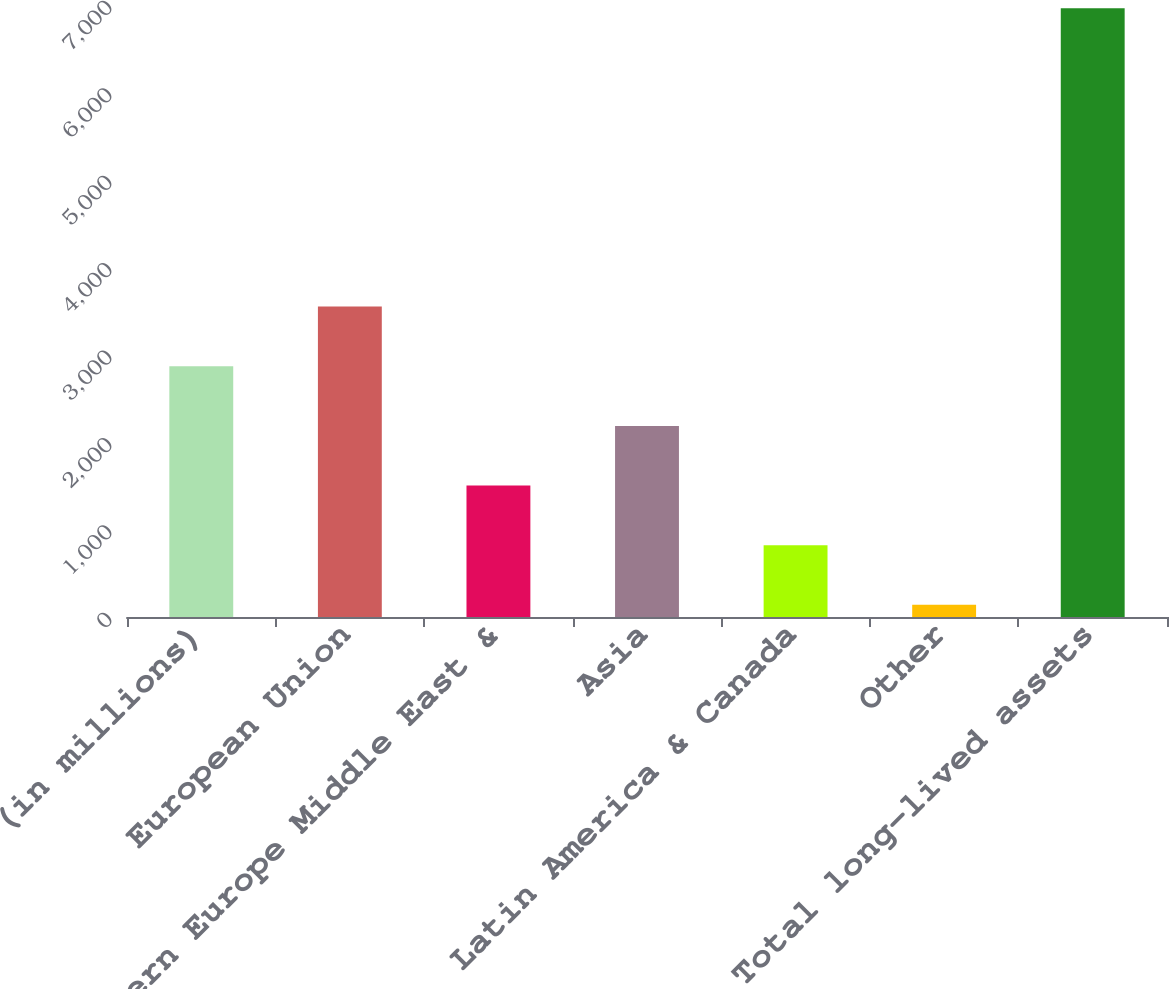Convert chart. <chart><loc_0><loc_0><loc_500><loc_500><bar_chart><fcel>(in millions)<fcel>European Union<fcel>Eastern Europe Middle East &<fcel>Asia<fcel>Latin America & Canada<fcel>Other<fcel>Total long-lived assets<nl><fcel>2868.2<fcel>3550.5<fcel>1503.6<fcel>2185.9<fcel>821.3<fcel>139<fcel>6962<nl></chart> 